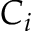<formula> <loc_0><loc_0><loc_500><loc_500>C _ { i }</formula> 